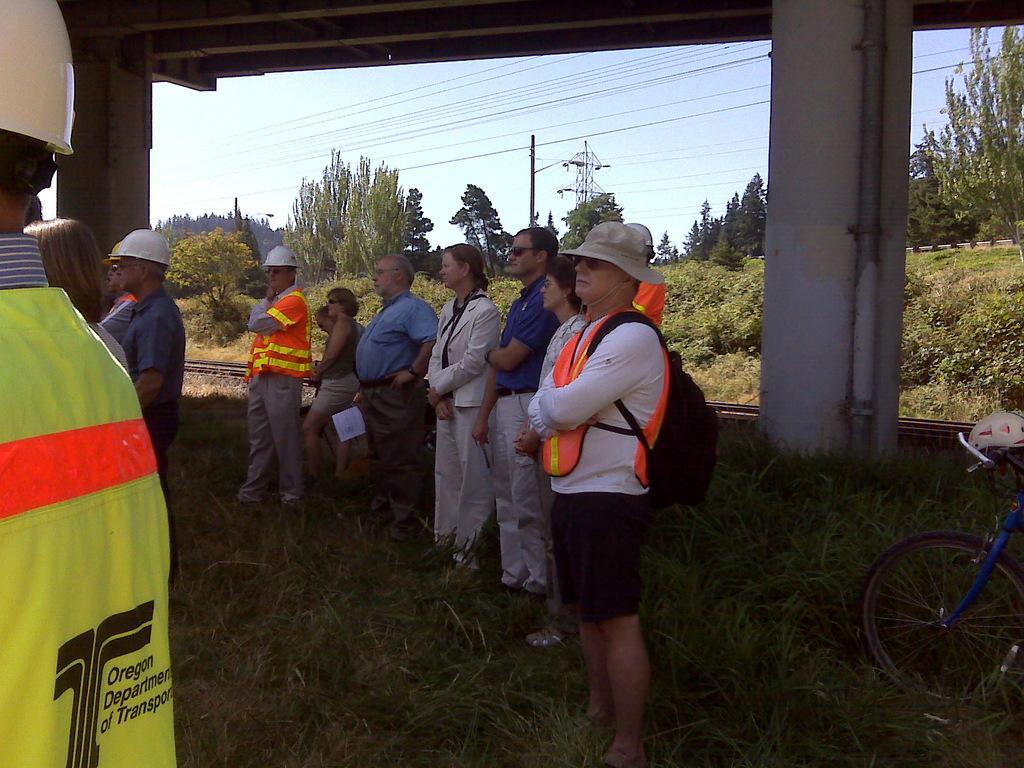Please provide a concise description of this image. In this picture we can see some group of people where some people are wearing jackets, cap, goggles and this person is holding paper in his hand and this all people are looking at something and they are standing on a grass and in background we can see pillar, wire to that piller,sky,wires and a tower, trees. 